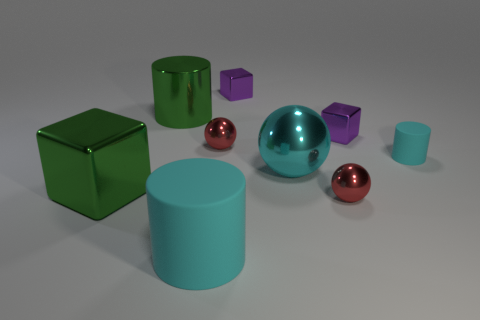Subtract all green metal cubes. How many cubes are left? 2 Subtract all green cubes. How many cubes are left? 2 Add 1 big things. How many objects exist? 10 Subtract 1 cylinders. How many cylinders are left? 2 Subtract 1 green cylinders. How many objects are left? 8 Subtract all cylinders. How many objects are left? 6 Subtract all cyan cylinders. Subtract all red balls. How many cylinders are left? 1 Subtract all red cylinders. How many brown spheres are left? 0 Subtract all cyan matte cylinders. Subtract all small red metal objects. How many objects are left? 5 Add 7 large blocks. How many large blocks are left? 8 